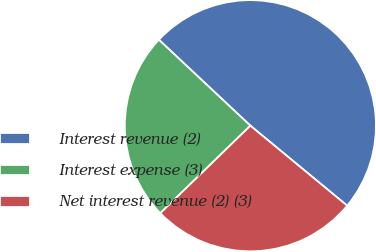<chart> <loc_0><loc_0><loc_500><loc_500><pie_chart><fcel>Interest revenue (2)<fcel>Interest expense (3)<fcel>Net interest revenue (2) (3)<nl><fcel>48.99%<fcel>24.27%<fcel>26.74%<nl></chart> 